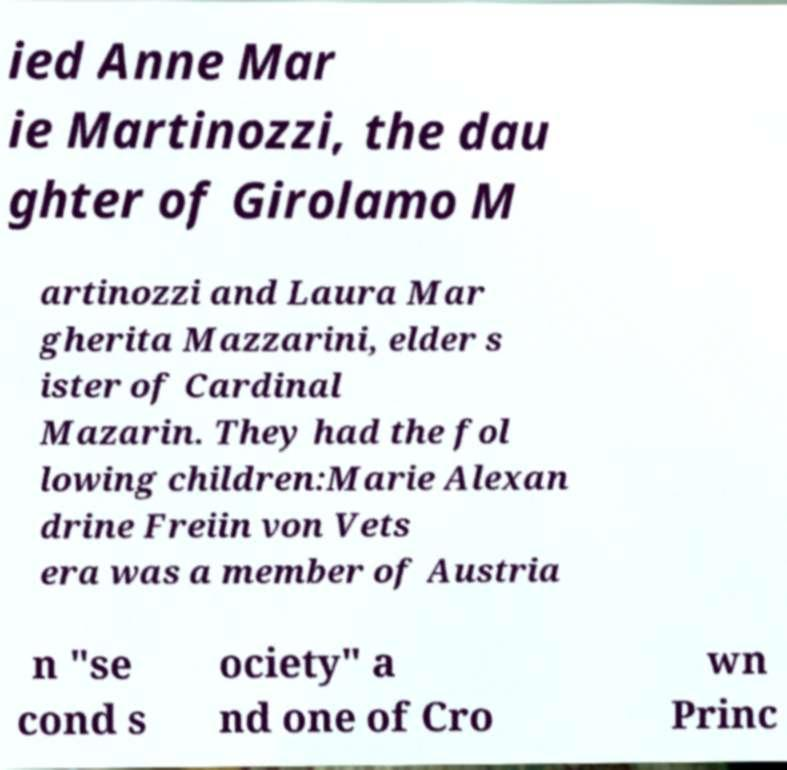Please identify and transcribe the text found in this image. ied Anne Mar ie Martinozzi, the dau ghter of Girolamo M artinozzi and Laura Mar gherita Mazzarini, elder s ister of Cardinal Mazarin. They had the fol lowing children:Marie Alexan drine Freiin von Vets era was a member of Austria n "se cond s ociety" a nd one of Cro wn Princ 